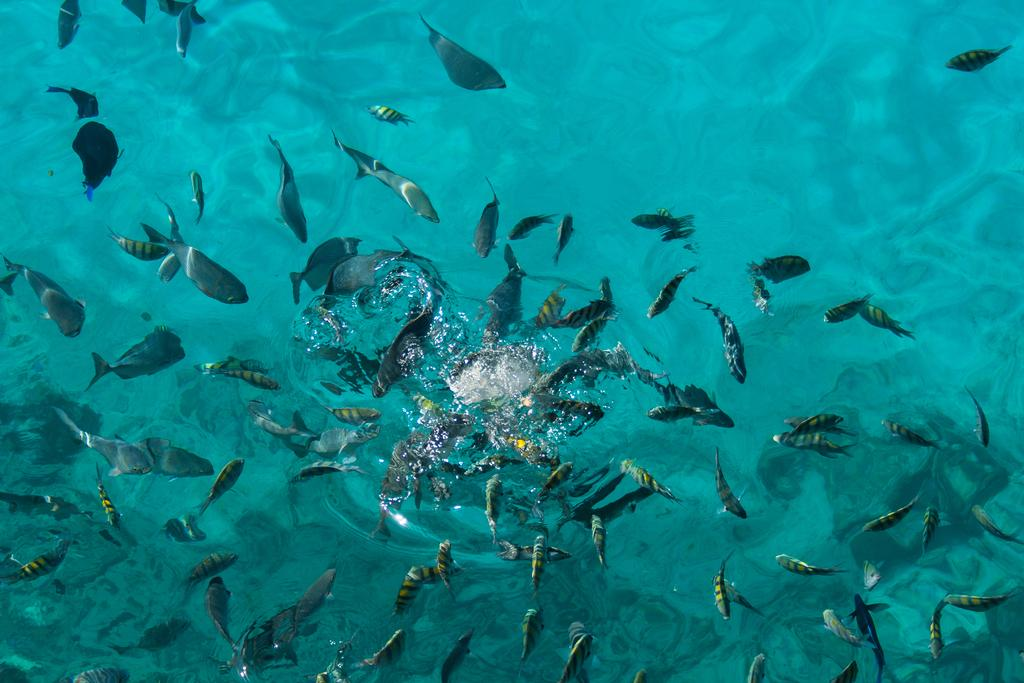What type of animals can be seen in the water in the image? There are fish in the water in the image. Can you describe the environment in which the fish are located? The fish are located in water, which suggests a natural or artificial body of water. What type of ticket is required to attend the meeting with the fish in the image? There is no meeting or ticket present in the image; it simply features fish in the water. 